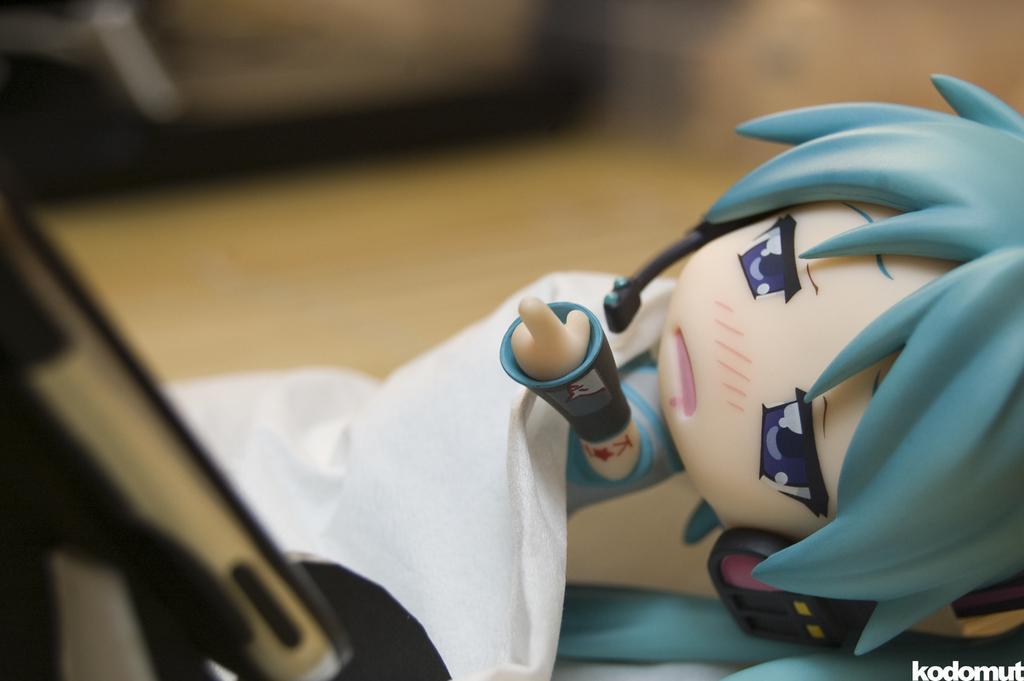Describe this image in one or two sentences. In this image there is a doll on the table. 